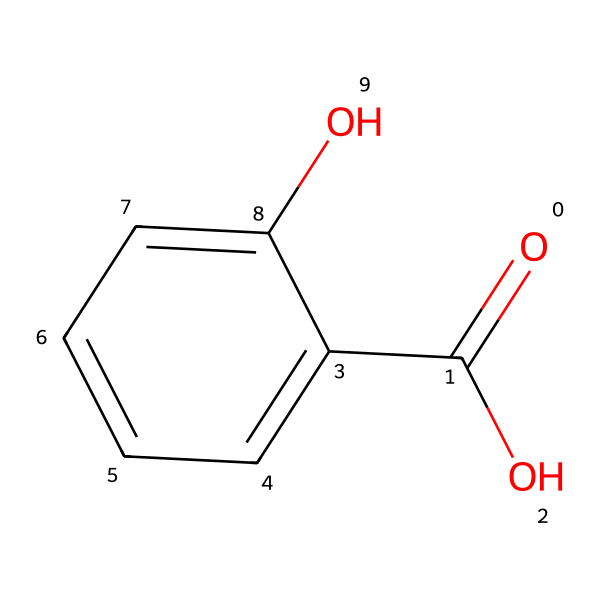What is the name of this compound? The SMILES representation corresponds to the chemical structure of salicylic acid, which is a known compound.
Answer: salicylic acid How many carbon atoms are in the structure? By analyzing the SMILES, we observe there are six carbon atoms in the benzene ring and one additional carbon in the carboxylic acid functional group, totaling seven carbon atoms.
Answer: seven What functional groups are present in this molecule? The structure reveals both a carboxylic acid group (–COOH) and a phenolic hydroxyl group (–OH), which are characteristic functional groups present in salicylic acid.
Answer: carboxylic acid and phenolic hydroxyl What type of aromatic compound is salicylic acid? Salicylic acid is classified as a phenolic compound due to the presence of the hydroxyl group attached to an aromatic benzene ring.
Answer: phenolic How many hydrogen atoms are attached to the carbon atoms in the molecule? The molecule has a total of four hydrogen atoms attached to the carbons in the benzene ring and one hydrogen in the hydroxyl group, accounting for a total of five hydrogen atoms in the structure.
Answer: five Which part of the molecule is responsible for its acidic property? The carboxylic acid functional group (–COOH) is the part of the molecule that exhibits acidic properties, as it can donate a proton (H+).
Answer: carboxylic acid How does salicylic acid affect plant stress responses? Salicylic acid plays a crucial role in plant defense mechanisms, enhancing resistance to biotic stress, such as pathogens and environmental stressors, acting as a signaling molecule in stress response pathways.
Answer: signaling molecule 